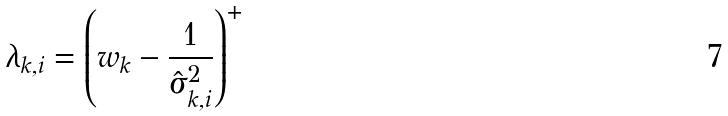Convert formula to latex. <formula><loc_0><loc_0><loc_500><loc_500>\lambda _ { k , i } = \left ( w _ { k } - \frac { 1 } { \hat { \sigma } _ { k , i } ^ { 2 } } \right ) ^ { + }</formula> 